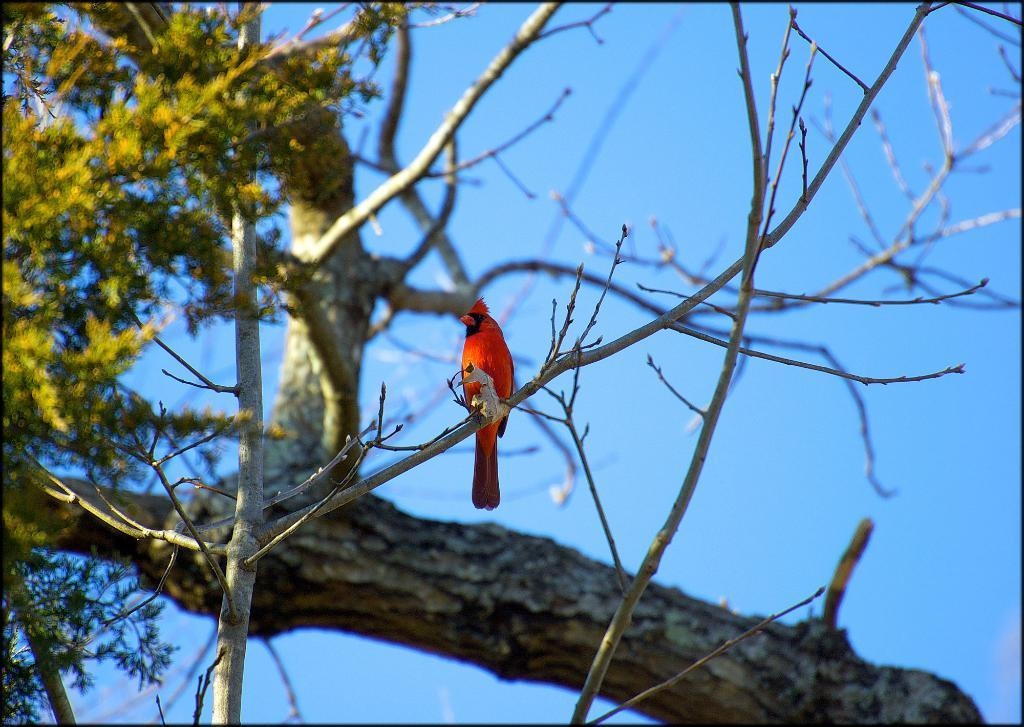What type of plant can be seen in the image? There is a tree in the image. What animal is present in the image? There is a bird in the image. What part of the natural environment is visible in the image? The sky is visible in the image. What type of quince is the bird holding in the image? There is no quince present in the image, and the bird is not holding anything. 